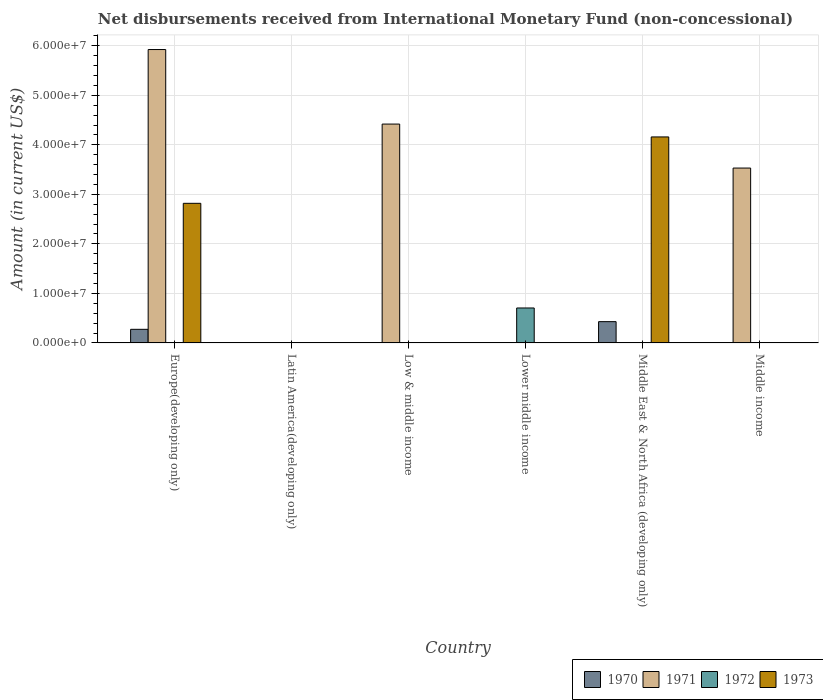How many different coloured bars are there?
Give a very brief answer. 4. What is the label of the 4th group of bars from the left?
Your answer should be very brief. Lower middle income. In how many cases, is the number of bars for a given country not equal to the number of legend labels?
Your answer should be compact. 6. Across all countries, what is the maximum amount of disbursements received from International Monetary Fund in 1972?
Your response must be concise. 7.06e+06. In which country was the amount of disbursements received from International Monetary Fund in 1971 maximum?
Your response must be concise. Europe(developing only). What is the total amount of disbursements received from International Monetary Fund in 1972 in the graph?
Your answer should be compact. 7.06e+06. What is the difference between the amount of disbursements received from International Monetary Fund in 1973 in Lower middle income and the amount of disbursements received from International Monetary Fund in 1972 in Middle income?
Give a very brief answer. 0. What is the average amount of disbursements received from International Monetary Fund in 1973 per country?
Your response must be concise. 1.16e+07. What is the difference between the amount of disbursements received from International Monetary Fund of/in 1970 and amount of disbursements received from International Monetary Fund of/in 1971 in Europe(developing only)?
Give a very brief answer. -5.65e+07. What is the difference between the highest and the second highest amount of disbursements received from International Monetary Fund in 1971?
Provide a succinct answer. 2.39e+07. What is the difference between the highest and the lowest amount of disbursements received from International Monetary Fund in 1972?
Your answer should be very brief. 7.06e+06. Is it the case that in every country, the sum of the amount of disbursements received from International Monetary Fund in 1971 and amount of disbursements received from International Monetary Fund in 1970 is greater than the sum of amount of disbursements received from International Monetary Fund in 1972 and amount of disbursements received from International Monetary Fund in 1973?
Make the answer very short. No. Is it the case that in every country, the sum of the amount of disbursements received from International Monetary Fund in 1970 and amount of disbursements received from International Monetary Fund in 1973 is greater than the amount of disbursements received from International Monetary Fund in 1972?
Ensure brevity in your answer.  No. How many countries are there in the graph?
Your answer should be compact. 6. Does the graph contain grids?
Keep it short and to the point. Yes. How many legend labels are there?
Make the answer very short. 4. What is the title of the graph?
Make the answer very short. Net disbursements received from International Monetary Fund (non-concessional). What is the label or title of the X-axis?
Provide a succinct answer. Country. What is the Amount (in current US$) of 1970 in Europe(developing only)?
Keep it short and to the point. 2.75e+06. What is the Amount (in current US$) of 1971 in Europe(developing only)?
Give a very brief answer. 5.92e+07. What is the Amount (in current US$) in 1973 in Europe(developing only)?
Keep it short and to the point. 2.82e+07. What is the Amount (in current US$) of 1971 in Latin America(developing only)?
Keep it short and to the point. 0. What is the Amount (in current US$) of 1972 in Latin America(developing only)?
Ensure brevity in your answer.  0. What is the Amount (in current US$) of 1971 in Low & middle income?
Keep it short and to the point. 4.42e+07. What is the Amount (in current US$) of 1972 in Low & middle income?
Your answer should be very brief. 0. What is the Amount (in current US$) of 1970 in Lower middle income?
Your answer should be very brief. 0. What is the Amount (in current US$) in 1972 in Lower middle income?
Provide a succinct answer. 7.06e+06. What is the Amount (in current US$) of 1970 in Middle East & North Africa (developing only)?
Offer a very short reply. 4.30e+06. What is the Amount (in current US$) in 1971 in Middle East & North Africa (developing only)?
Your answer should be compact. 0. What is the Amount (in current US$) of 1972 in Middle East & North Africa (developing only)?
Make the answer very short. 0. What is the Amount (in current US$) of 1973 in Middle East & North Africa (developing only)?
Keep it short and to the point. 4.16e+07. What is the Amount (in current US$) in 1970 in Middle income?
Ensure brevity in your answer.  0. What is the Amount (in current US$) of 1971 in Middle income?
Provide a short and direct response. 3.53e+07. What is the Amount (in current US$) of 1972 in Middle income?
Give a very brief answer. 0. Across all countries, what is the maximum Amount (in current US$) of 1970?
Offer a terse response. 4.30e+06. Across all countries, what is the maximum Amount (in current US$) in 1971?
Offer a very short reply. 5.92e+07. Across all countries, what is the maximum Amount (in current US$) in 1972?
Your answer should be compact. 7.06e+06. Across all countries, what is the maximum Amount (in current US$) in 1973?
Your answer should be compact. 4.16e+07. Across all countries, what is the minimum Amount (in current US$) of 1973?
Provide a short and direct response. 0. What is the total Amount (in current US$) in 1970 in the graph?
Your answer should be very brief. 7.05e+06. What is the total Amount (in current US$) in 1971 in the graph?
Ensure brevity in your answer.  1.39e+08. What is the total Amount (in current US$) in 1972 in the graph?
Provide a short and direct response. 7.06e+06. What is the total Amount (in current US$) in 1973 in the graph?
Your answer should be very brief. 6.98e+07. What is the difference between the Amount (in current US$) in 1971 in Europe(developing only) and that in Low & middle income?
Provide a succinct answer. 1.50e+07. What is the difference between the Amount (in current US$) in 1970 in Europe(developing only) and that in Middle East & North Africa (developing only)?
Offer a terse response. -1.55e+06. What is the difference between the Amount (in current US$) of 1973 in Europe(developing only) and that in Middle East & North Africa (developing only)?
Your response must be concise. -1.34e+07. What is the difference between the Amount (in current US$) in 1971 in Europe(developing only) and that in Middle income?
Provide a short and direct response. 2.39e+07. What is the difference between the Amount (in current US$) of 1971 in Low & middle income and that in Middle income?
Your answer should be compact. 8.88e+06. What is the difference between the Amount (in current US$) in 1970 in Europe(developing only) and the Amount (in current US$) in 1971 in Low & middle income?
Provide a short and direct response. -4.14e+07. What is the difference between the Amount (in current US$) of 1970 in Europe(developing only) and the Amount (in current US$) of 1972 in Lower middle income?
Your answer should be compact. -4.31e+06. What is the difference between the Amount (in current US$) in 1971 in Europe(developing only) and the Amount (in current US$) in 1972 in Lower middle income?
Make the answer very short. 5.22e+07. What is the difference between the Amount (in current US$) in 1970 in Europe(developing only) and the Amount (in current US$) in 1973 in Middle East & North Africa (developing only)?
Offer a terse response. -3.88e+07. What is the difference between the Amount (in current US$) of 1971 in Europe(developing only) and the Amount (in current US$) of 1973 in Middle East & North Africa (developing only)?
Your answer should be very brief. 1.76e+07. What is the difference between the Amount (in current US$) of 1970 in Europe(developing only) and the Amount (in current US$) of 1971 in Middle income?
Give a very brief answer. -3.26e+07. What is the difference between the Amount (in current US$) in 1971 in Low & middle income and the Amount (in current US$) in 1972 in Lower middle income?
Your answer should be compact. 3.71e+07. What is the difference between the Amount (in current US$) of 1971 in Low & middle income and the Amount (in current US$) of 1973 in Middle East & North Africa (developing only)?
Ensure brevity in your answer.  2.60e+06. What is the difference between the Amount (in current US$) in 1972 in Lower middle income and the Amount (in current US$) in 1973 in Middle East & North Africa (developing only)?
Ensure brevity in your answer.  -3.45e+07. What is the difference between the Amount (in current US$) of 1970 in Middle East & North Africa (developing only) and the Amount (in current US$) of 1971 in Middle income?
Your response must be concise. -3.10e+07. What is the average Amount (in current US$) in 1970 per country?
Give a very brief answer. 1.18e+06. What is the average Amount (in current US$) of 1971 per country?
Give a very brief answer. 2.31e+07. What is the average Amount (in current US$) in 1972 per country?
Make the answer very short. 1.18e+06. What is the average Amount (in current US$) in 1973 per country?
Your answer should be compact. 1.16e+07. What is the difference between the Amount (in current US$) of 1970 and Amount (in current US$) of 1971 in Europe(developing only)?
Make the answer very short. -5.65e+07. What is the difference between the Amount (in current US$) in 1970 and Amount (in current US$) in 1973 in Europe(developing only)?
Your answer should be very brief. -2.54e+07. What is the difference between the Amount (in current US$) of 1971 and Amount (in current US$) of 1973 in Europe(developing only)?
Your response must be concise. 3.10e+07. What is the difference between the Amount (in current US$) in 1970 and Amount (in current US$) in 1973 in Middle East & North Africa (developing only)?
Offer a terse response. -3.73e+07. What is the ratio of the Amount (in current US$) in 1971 in Europe(developing only) to that in Low & middle income?
Keep it short and to the point. 1.34. What is the ratio of the Amount (in current US$) in 1970 in Europe(developing only) to that in Middle East & North Africa (developing only)?
Keep it short and to the point. 0.64. What is the ratio of the Amount (in current US$) in 1973 in Europe(developing only) to that in Middle East & North Africa (developing only)?
Your response must be concise. 0.68. What is the ratio of the Amount (in current US$) of 1971 in Europe(developing only) to that in Middle income?
Make the answer very short. 1.68. What is the ratio of the Amount (in current US$) of 1971 in Low & middle income to that in Middle income?
Give a very brief answer. 1.25. What is the difference between the highest and the second highest Amount (in current US$) in 1971?
Make the answer very short. 1.50e+07. What is the difference between the highest and the lowest Amount (in current US$) in 1970?
Keep it short and to the point. 4.30e+06. What is the difference between the highest and the lowest Amount (in current US$) of 1971?
Offer a very short reply. 5.92e+07. What is the difference between the highest and the lowest Amount (in current US$) in 1972?
Offer a terse response. 7.06e+06. What is the difference between the highest and the lowest Amount (in current US$) of 1973?
Your answer should be very brief. 4.16e+07. 